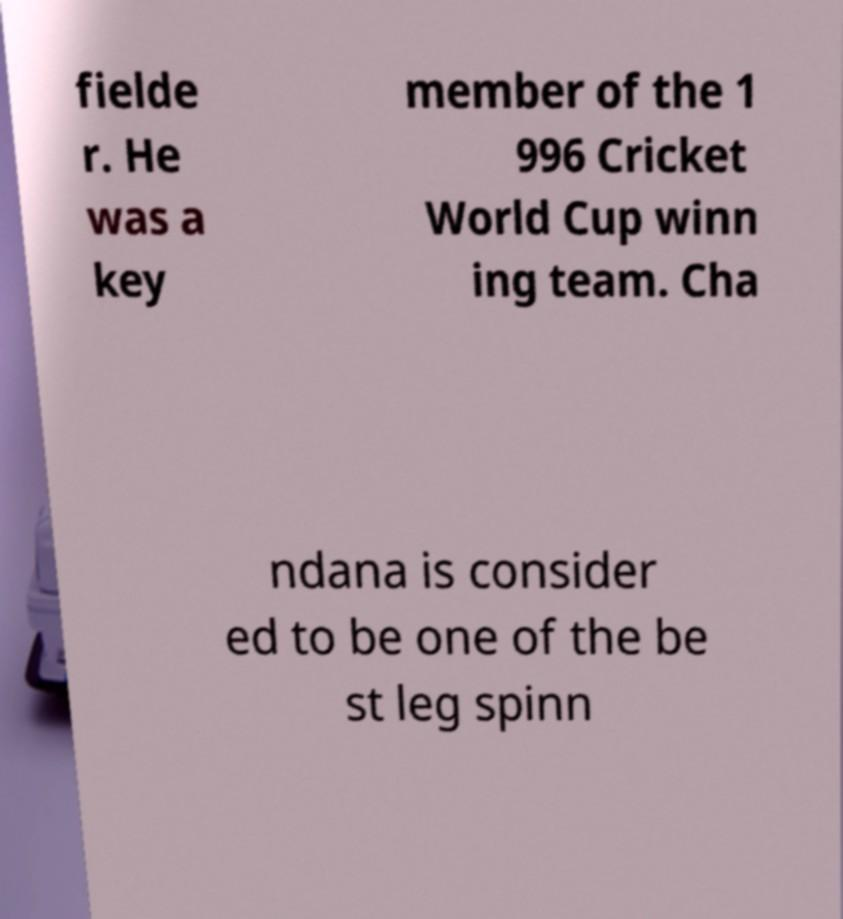Can you read and provide the text displayed in the image?This photo seems to have some interesting text. Can you extract and type it out for me? fielde r. He was a key member of the 1 996 Cricket World Cup winn ing team. Cha ndana is consider ed to be one of the be st leg spinn 